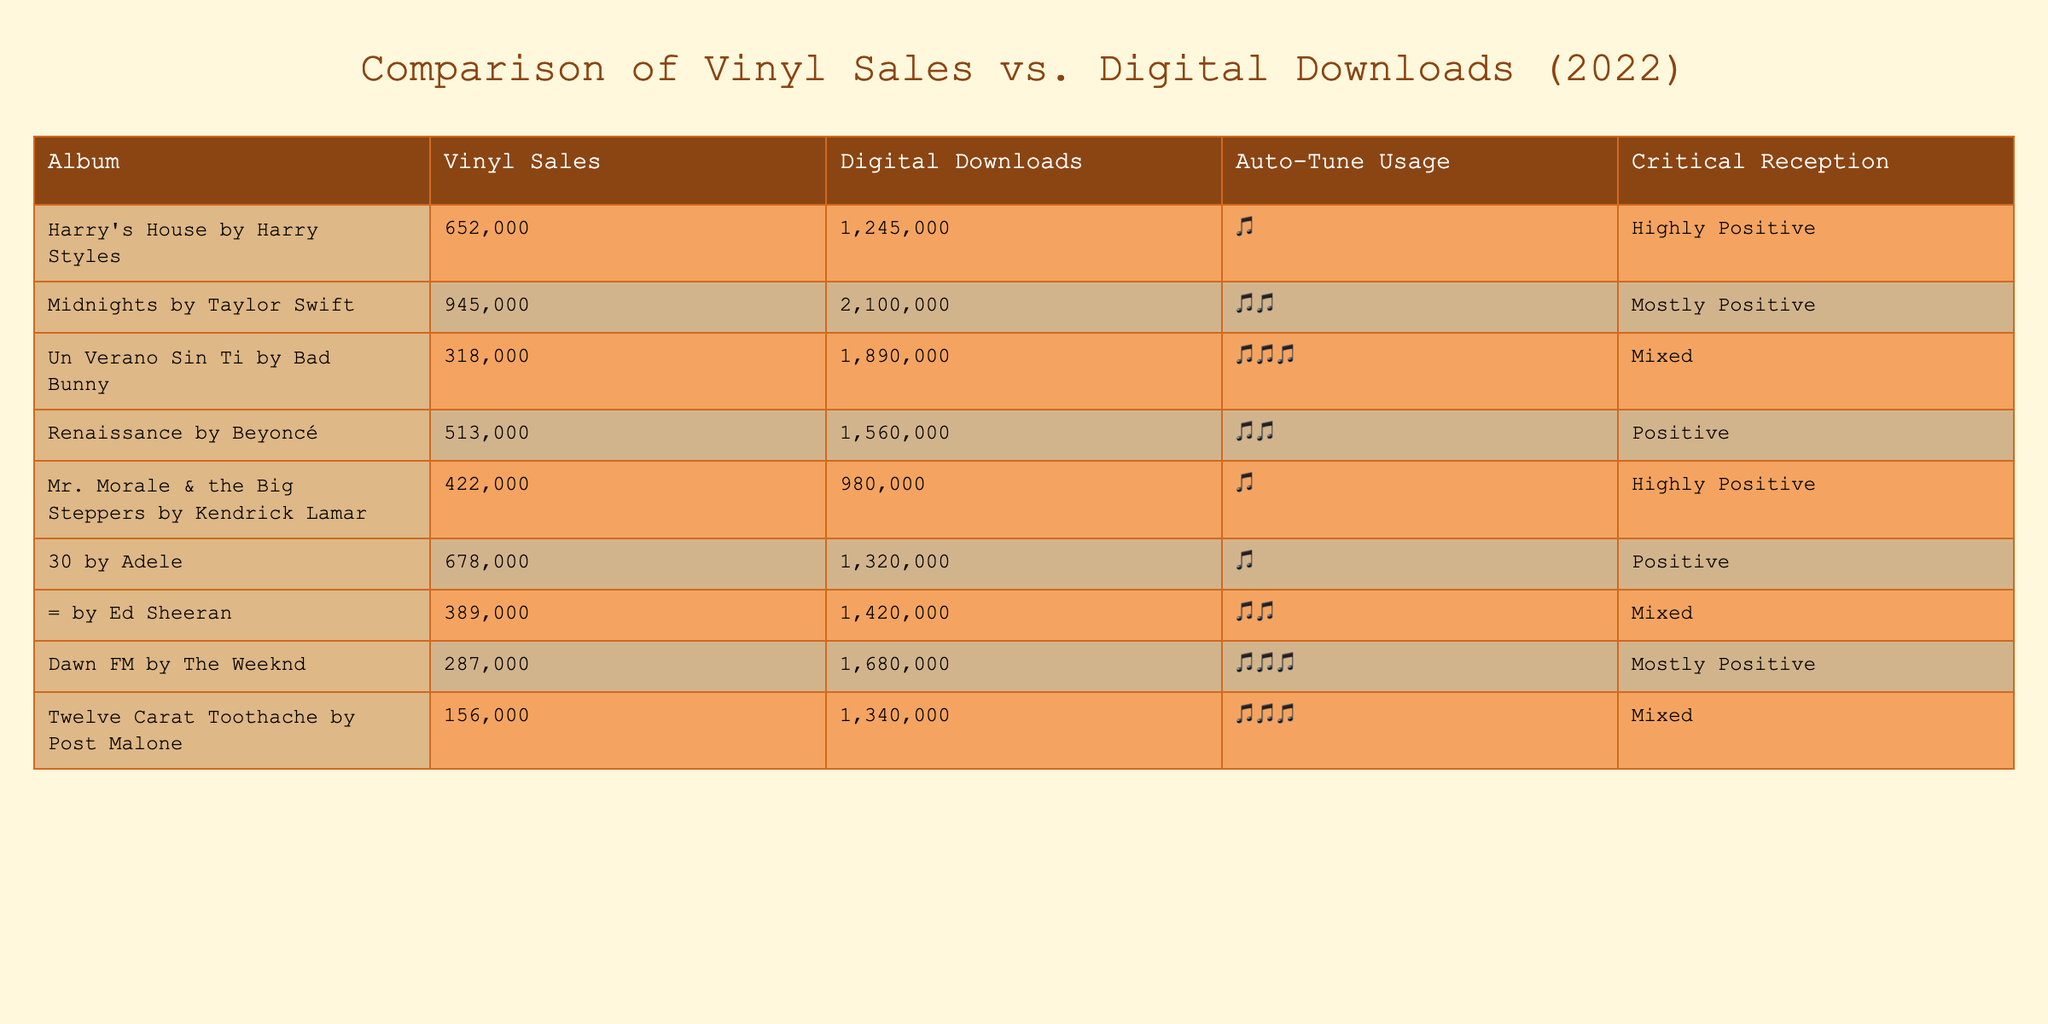What album had the highest vinyl sales in 2022? The table shows that "Midnights" by Taylor Swift had the highest vinyl sales with 945,000 copies sold.
Answer: "Midnights" by Taylor Swift How many digital downloads did "Harry's House" have? From the table, it states that "Harry's House" by Harry Styles had 1,245,000 digital downloads.
Answer: 1,245,000 What was the total vinyl sales for the top three albums? To find the total, we sum the vinyl sales of the top three albums: 945,000 ("Midnights") + 652,000 ("Harry's House") + 678,000 ("30") = 2,275,000.
Answer: 2,275,000 Is "Dawn FM" by The Weeknd considered to use Heavy Auto-Tune? Yes, according to the table, "Dawn FM" by The Weeknd is marked with Heavy Auto-Tune usage.
Answer: Yes Which album had the lowest digital downloads, and how many were there? The album with the lowest digital downloads is "Twelve Carat Toothache" by Post Malone, with 1,340,000 downloads.
Answer: "Twelve Carat Toothache" by Post Malone, 1,340,000 How does the vinyl sales of "Renaissance" compare to its digital downloads? "Renaissance" had 513,000 vinyl sales and 1,560,000 digital downloads. Therefore, the digital downloads (1,560,000) were significantly higher than vinyl sales (513,000).
Answer: Digital downloads were significantly higher What percentage of "30"'s digital downloads were vinyl sales? To find the percentage, divide vinyl sales (678,000) by digital downloads (1,320,000), which equals (678,000 / 1,320,000) * 100 = 51.36%. So vinyl sales made up about 51.36% of the digital downloads.
Answer: 51.36% Do all albums in the table have either Minimal or Moderate Auto-Tune usage? No, "Un Verano Sin Ti" and "Dawn FM" are marked as having Heavy Auto-Tune usage according to the table.
Answer: No Calculate the average digital downloads for all albums. First, add up the digital downloads: 1,245,000 + 2,100,000 + 1,890,000 + 1,560,000 + 980,000 + 1,320,000 + 1,420,000 + 1,680,000 + 1,340,000 = 13,458,000. Then divide by 10 (for the 10 albums): 13,458,000 / 10 = 1,345,800. Therefore, the average digital downloads for all albums is 1,345,800.
Answer: 1,345,800 